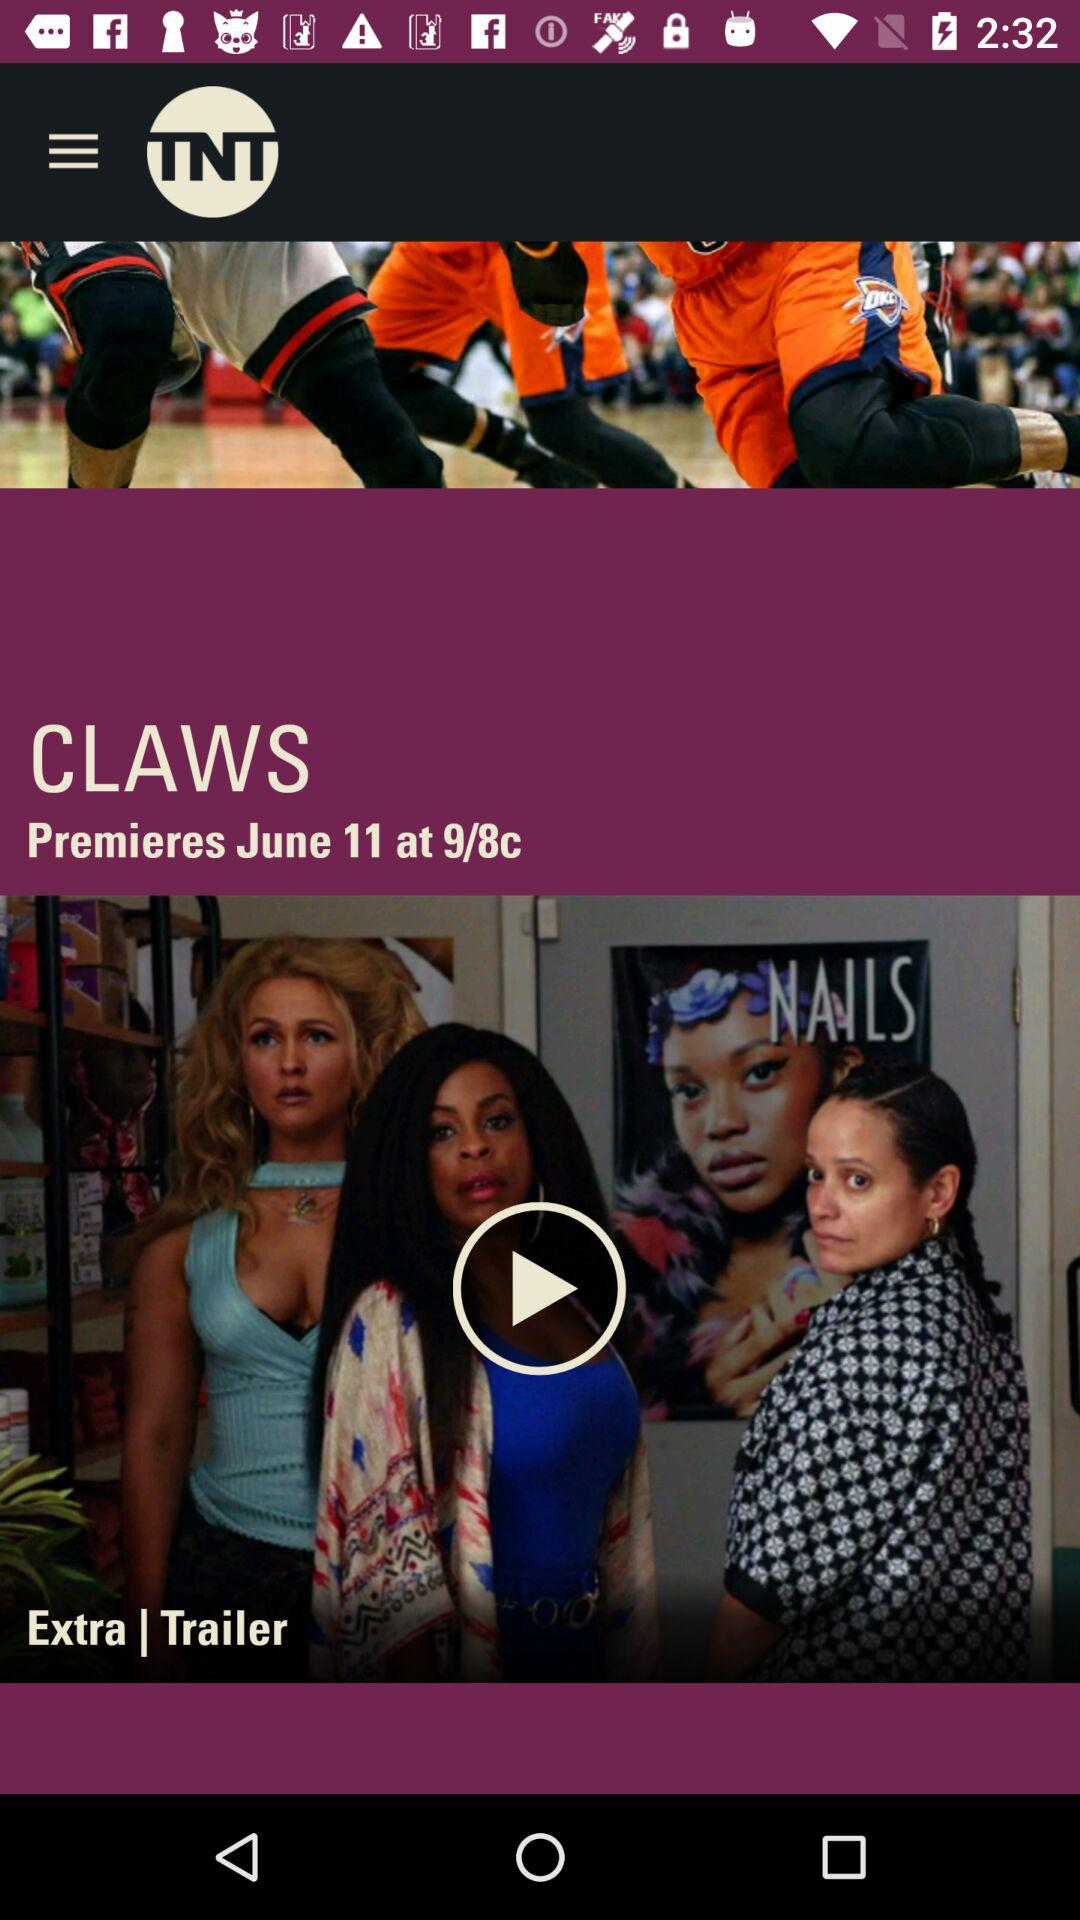What is the date of the "CLAWS" premiere? The date of the "CLAWS" premiere is June 11. 